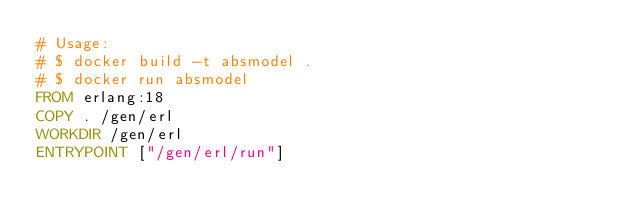<code> <loc_0><loc_0><loc_500><loc_500><_Dockerfile_># Usage:
# $ docker build -t absmodel .
# $ docker run absmodel
FROM erlang:18
COPY . /gen/erl
WORKDIR /gen/erl
ENTRYPOINT ["/gen/erl/run"]
</code> 